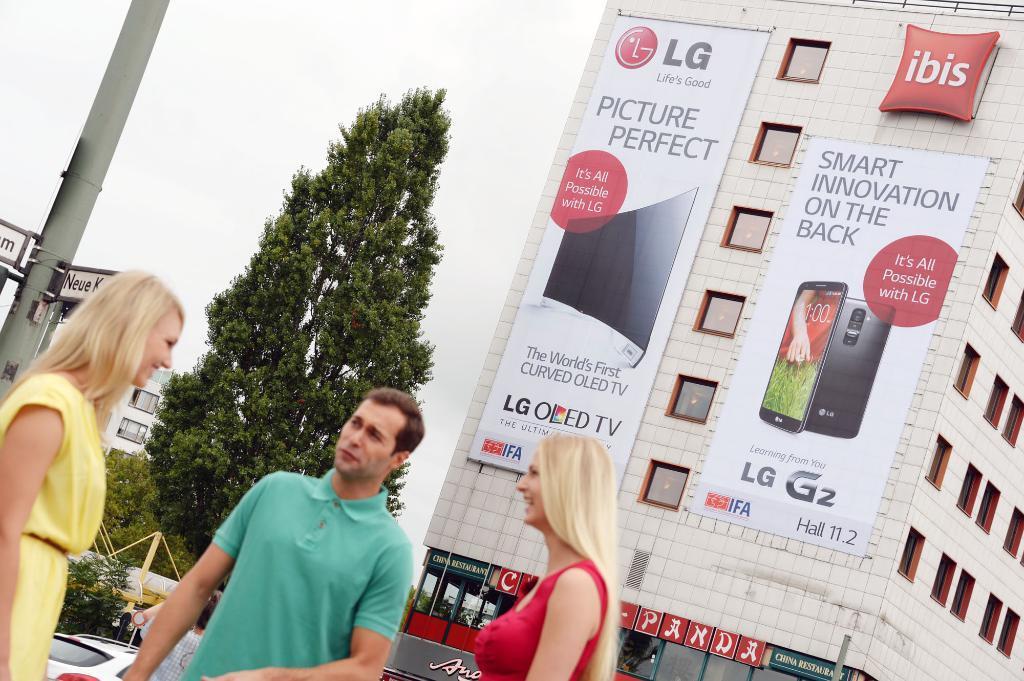How would you summarize this image in a sentence or two? In this picture I can observe three members. Two of them are women and one of them is a man. All of them are smiling. On the right side I can observe a building on which there are two posters. Beside the building there is a tree. On the left side there is a pole. In the background there is sky. 